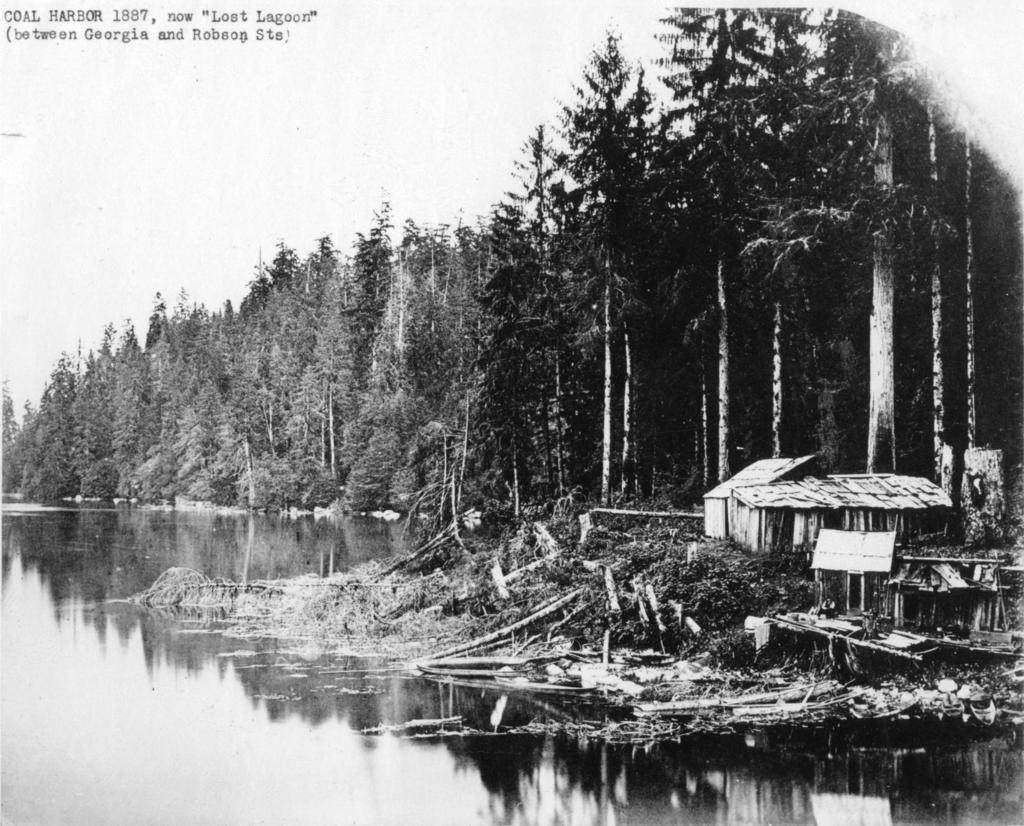How would you summarize this image in a sentence or two? In this image in front there is water. On the right side of the image there is a hut and a few other objects. In the background of the image there are trees and sky. 